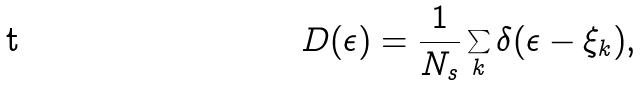<formula> <loc_0><loc_0><loc_500><loc_500>D ( \epsilon ) = \frac { 1 } { N _ { s } } \sum _ { k } \delta ( \epsilon - \xi _ { k } ) ,</formula> 